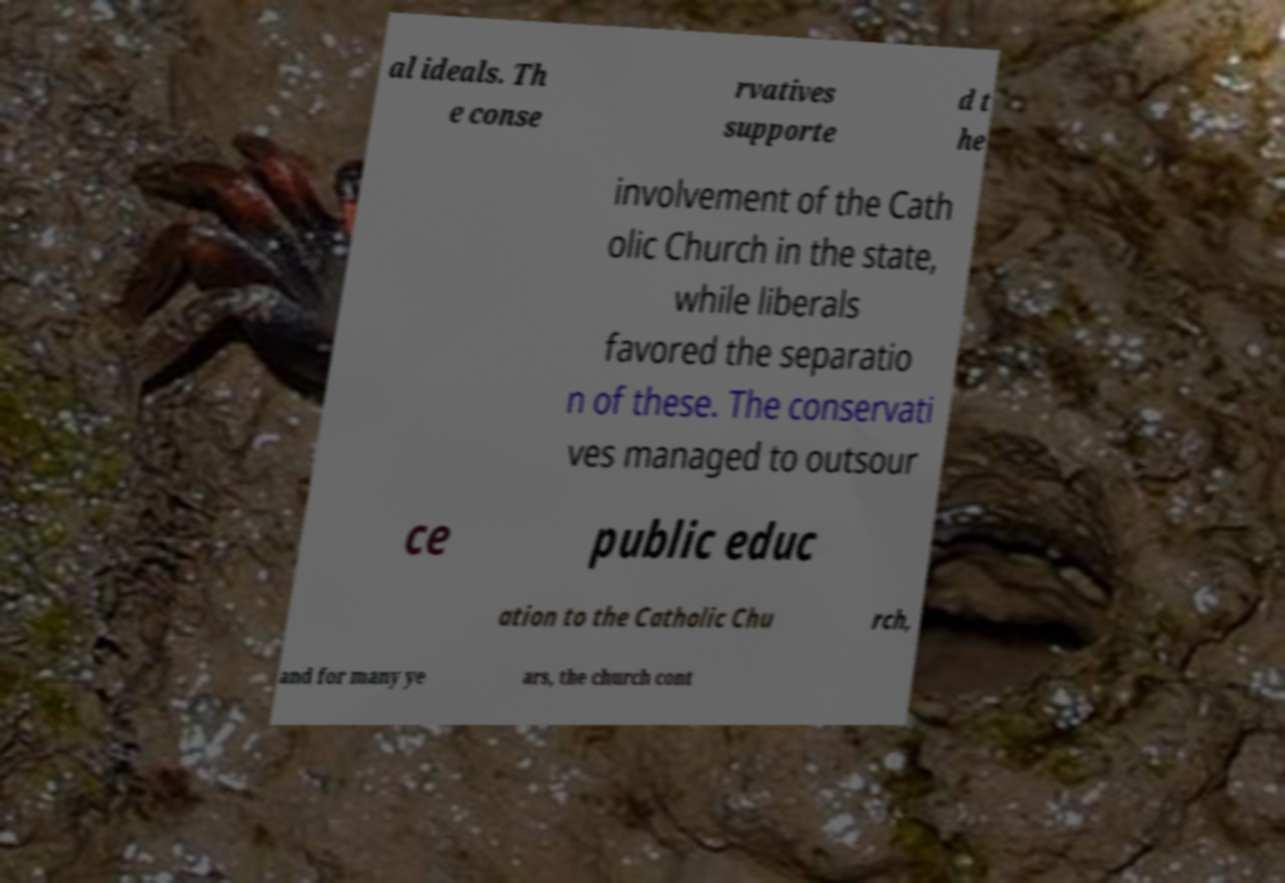For documentation purposes, I need the text within this image transcribed. Could you provide that? al ideals. Th e conse rvatives supporte d t he involvement of the Cath olic Church in the state, while liberals favored the separatio n of these. The conservati ves managed to outsour ce public educ ation to the Catholic Chu rch, and for many ye ars, the church cont 